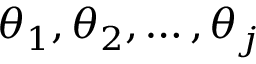<formula> <loc_0><loc_0><loc_500><loc_500>\theta _ { 1 } , \theta _ { 2 } , \dots , \theta _ { j }</formula> 